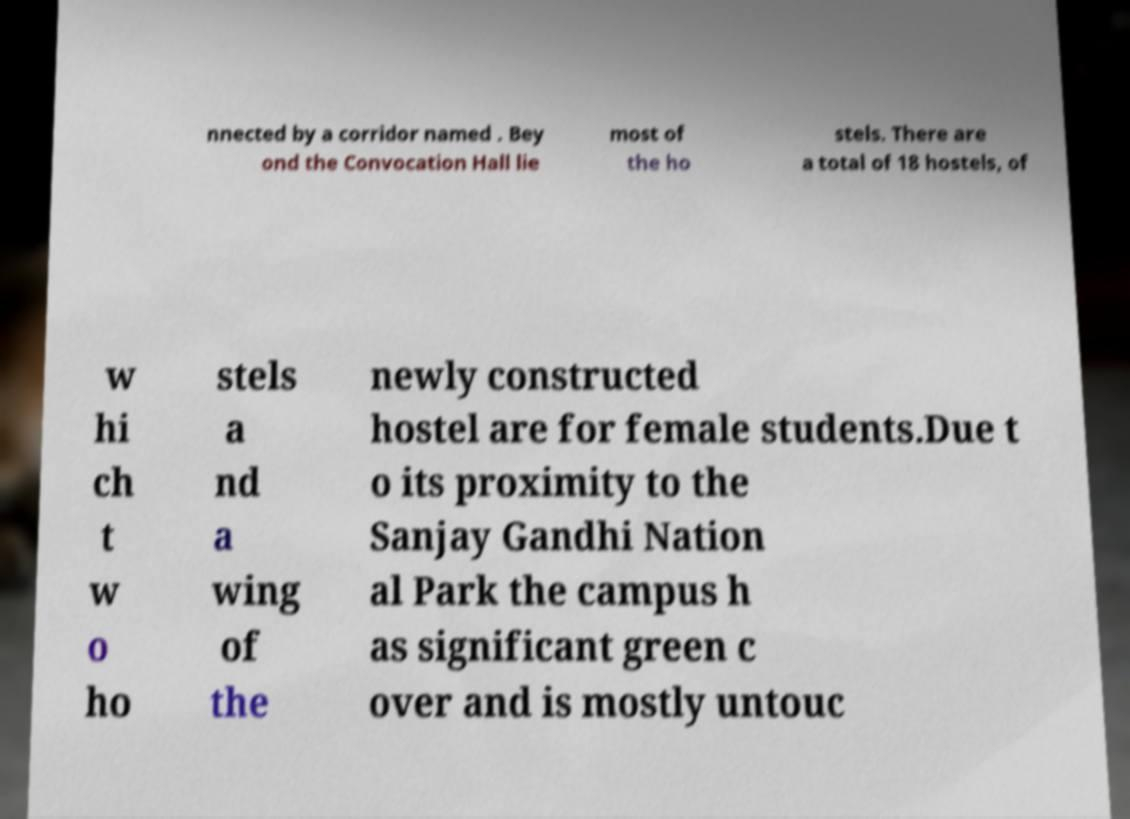For documentation purposes, I need the text within this image transcribed. Could you provide that? nnected by a corridor named . Bey ond the Convocation Hall lie most of the ho stels. There are a total of 18 hostels, of w hi ch t w o ho stels a nd a wing of the newly constructed hostel are for female students.Due t o its proximity to the Sanjay Gandhi Nation al Park the campus h as significant green c over and is mostly untouc 